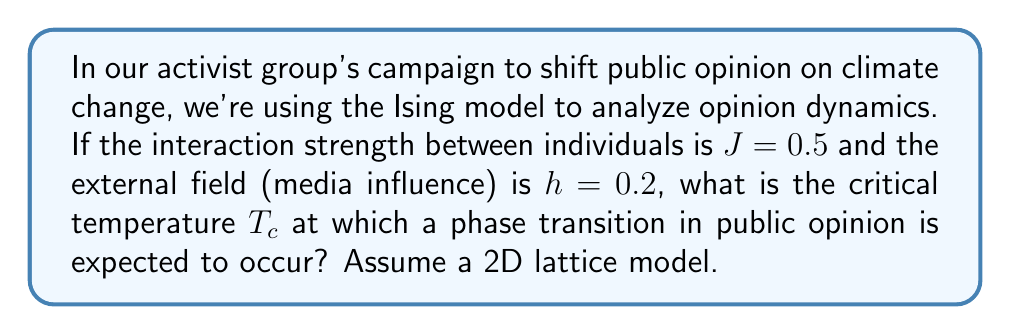Teach me how to tackle this problem. To solve this problem, we'll follow these steps:

1) The critical temperature $T_c$ for the 2D Ising model is given by the Onsager solution:

   $$T_c = \frac{2J}{k_B \ln(1+\sqrt{2})}$$

   where $J$ is the interaction strength and $k_B$ is the Boltzmann constant.

2) We're given $J = 0.5$. For simplicity, let's assume $k_B = 1$ (we can consider the temperature in energy units).

3) Substituting these values into the equation:

   $$T_c = \frac{2(0.5)}{\ln(1+\sqrt{2})}$$

4) Simplify:
   $$T_c = \frac{1}{\ln(1+\sqrt{2})}$$

5) Calculate:
   $$T_c \approx 1.1345$$

Note: The external field $h$ doesn't affect the critical temperature in the Ising model, but it does influence the sharpness of the phase transition.
Answer: $T_c \approx 1.1345$ 